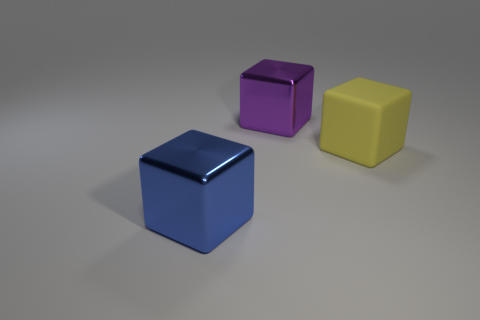Are the blocks arranged in any particular pattern or sequence? The blocks are not arranged in a recognizable pattern but are placed in a row with even spacing. The sequence from left to right is blue, purple, and yellow, creating a visually pleasing spread of primary and secondary colors. 